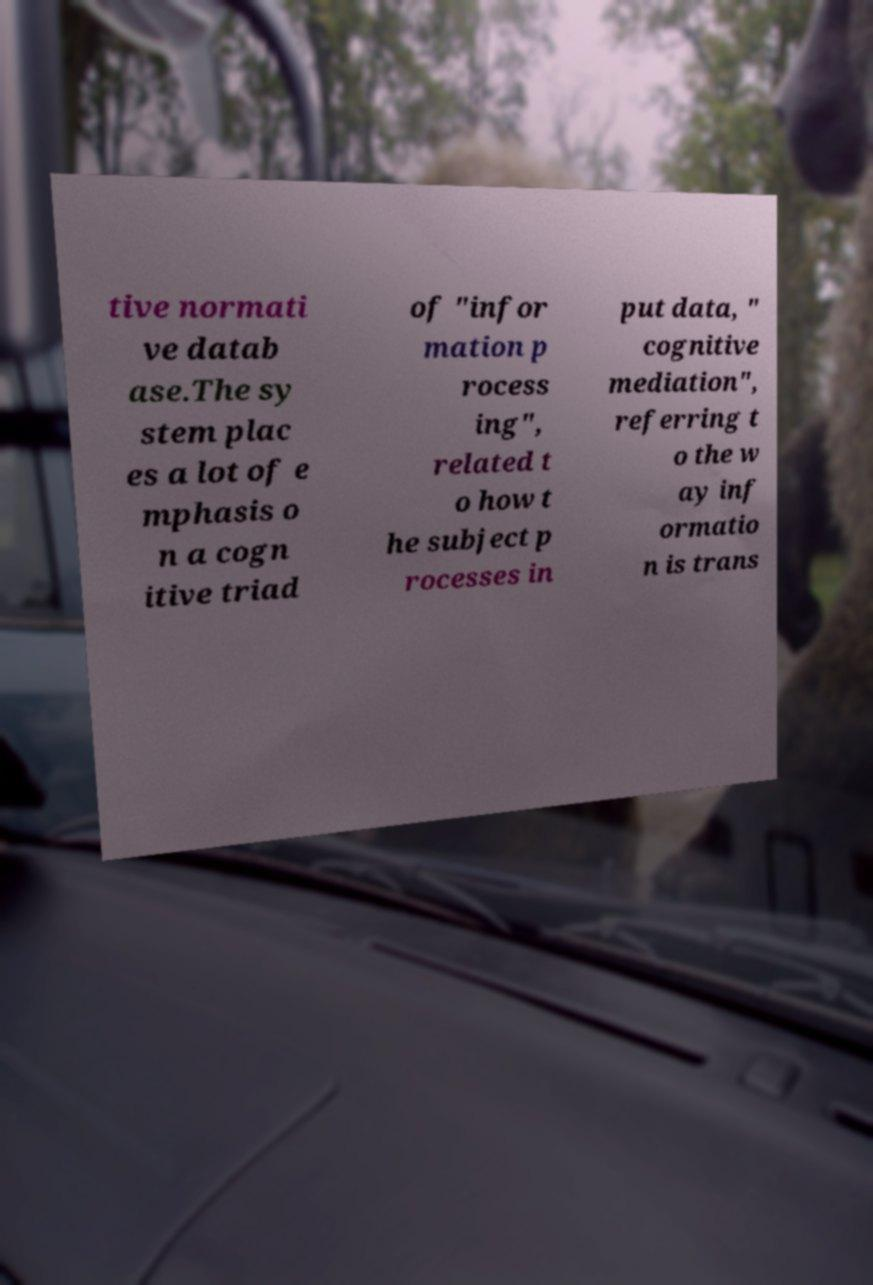Could you assist in decoding the text presented in this image and type it out clearly? tive normati ve datab ase.The sy stem plac es a lot of e mphasis o n a cogn itive triad of "infor mation p rocess ing", related t o how t he subject p rocesses in put data, " cognitive mediation", referring t o the w ay inf ormatio n is trans 